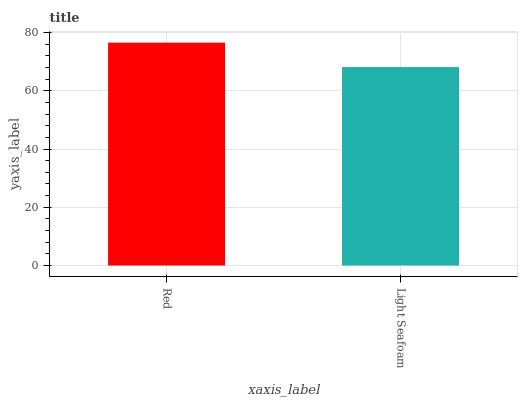Is Light Seafoam the minimum?
Answer yes or no. Yes. Is Red the maximum?
Answer yes or no. Yes. Is Light Seafoam the maximum?
Answer yes or no. No. Is Red greater than Light Seafoam?
Answer yes or no. Yes. Is Light Seafoam less than Red?
Answer yes or no. Yes. Is Light Seafoam greater than Red?
Answer yes or no. No. Is Red less than Light Seafoam?
Answer yes or no. No. Is Red the high median?
Answer yes or no. Yes. Is Light Seafoam the low median?
Answer yes or no. Yes. Is Light Seafoam the high median?
Answer yes or no. No. Is Red the low median?
Answer yes or no. No. 